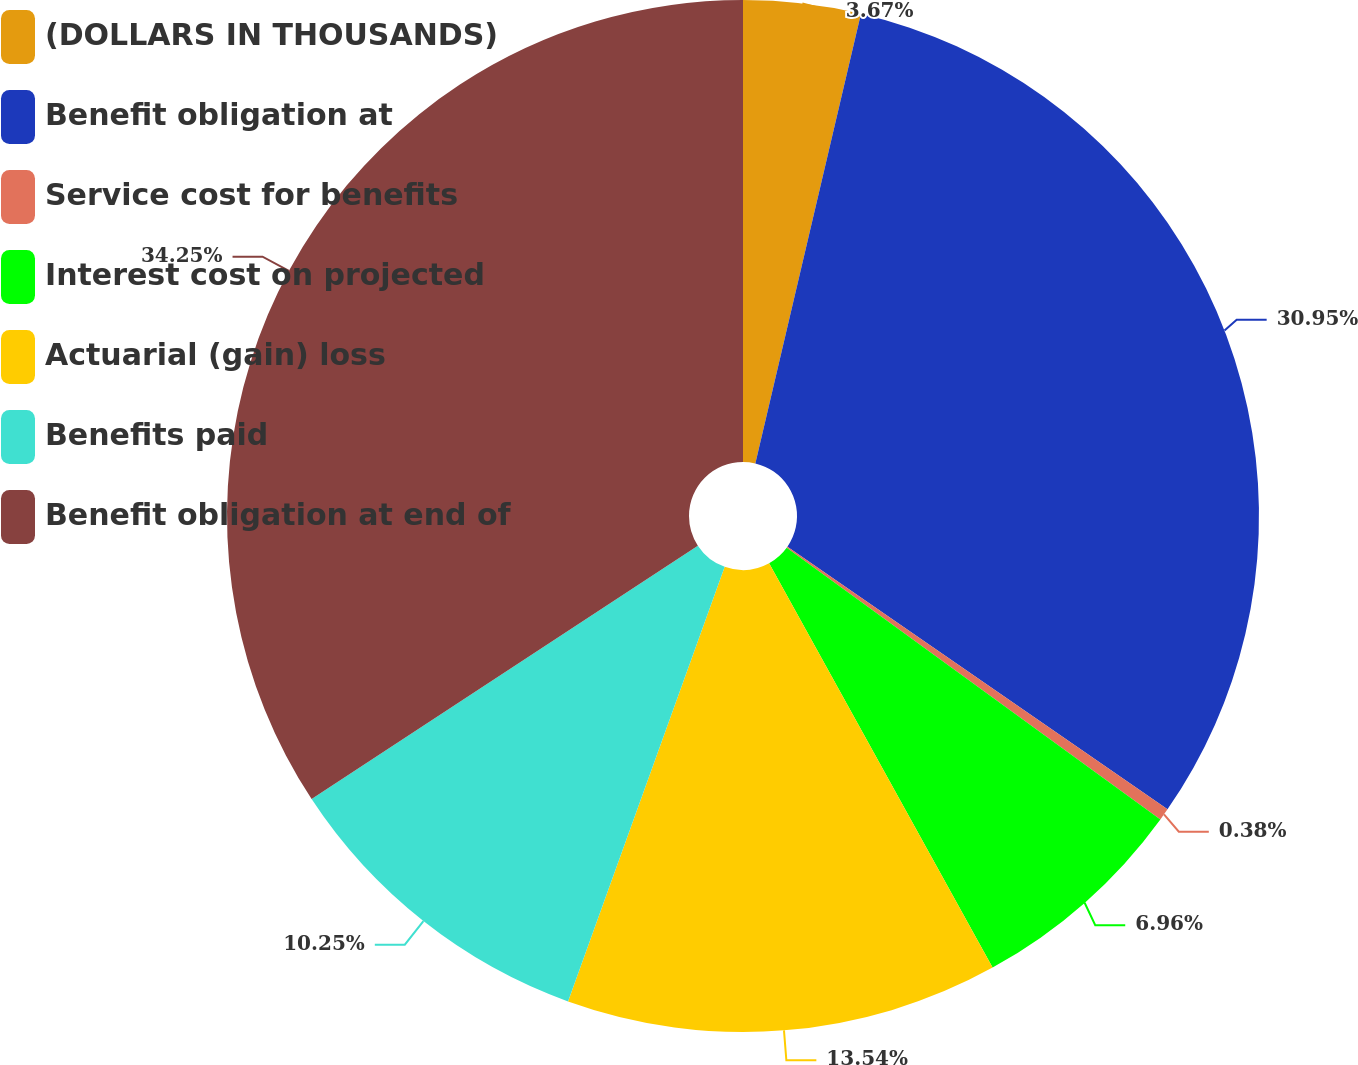Convert chart. <chart><loc_0><loc_0><loc_500><loc_500><pie_chart><fcel>(DOLLARS IN THOUSANDS)<fcel>Benefit obligation at<fcel>Service cost for benefits<fcel>Interest cost on projected<fcel>Actuarial (gain) loss<fcel>Benefits paid<fcel>Benefit obligation at end of<nl><fcel>3.67%<fcel>30.95%<fcel>0.38%<fcel>6.96%<fcel>13.54%<fcel>10.25%<fcel>34.24%<nl></chart> 